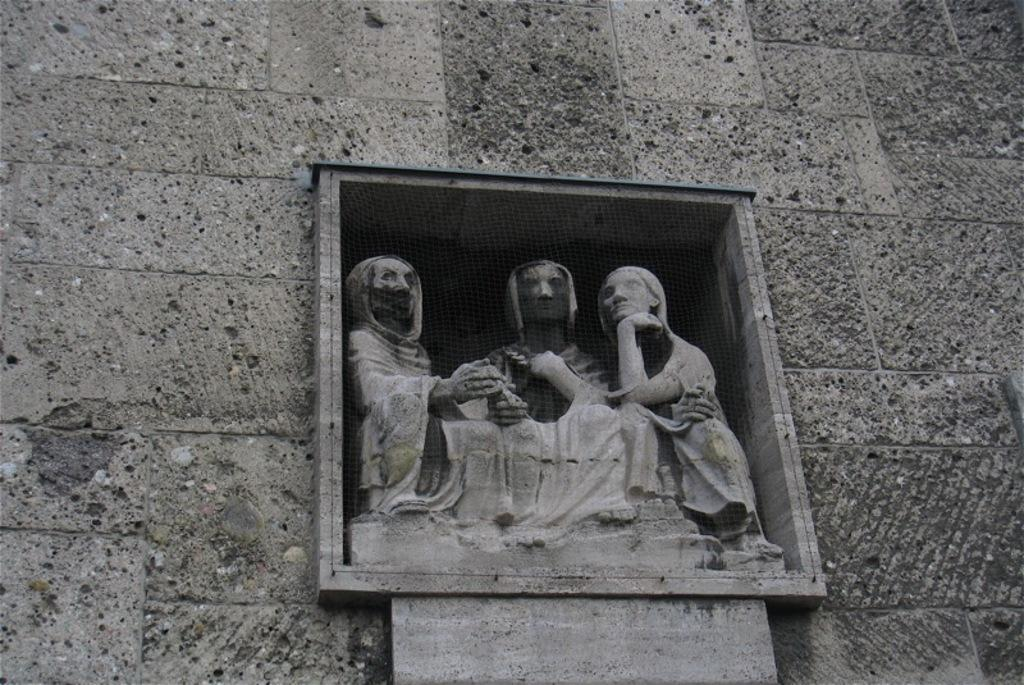What type of art is present in the image? There are sculptures in the image. What is visible in the background of the image? There is a wall in the background of the image. What type of cloud can be seen in the middle of the sculptures in the image? There is no cloud present in the image; it features sculptures and a wall in the background. 